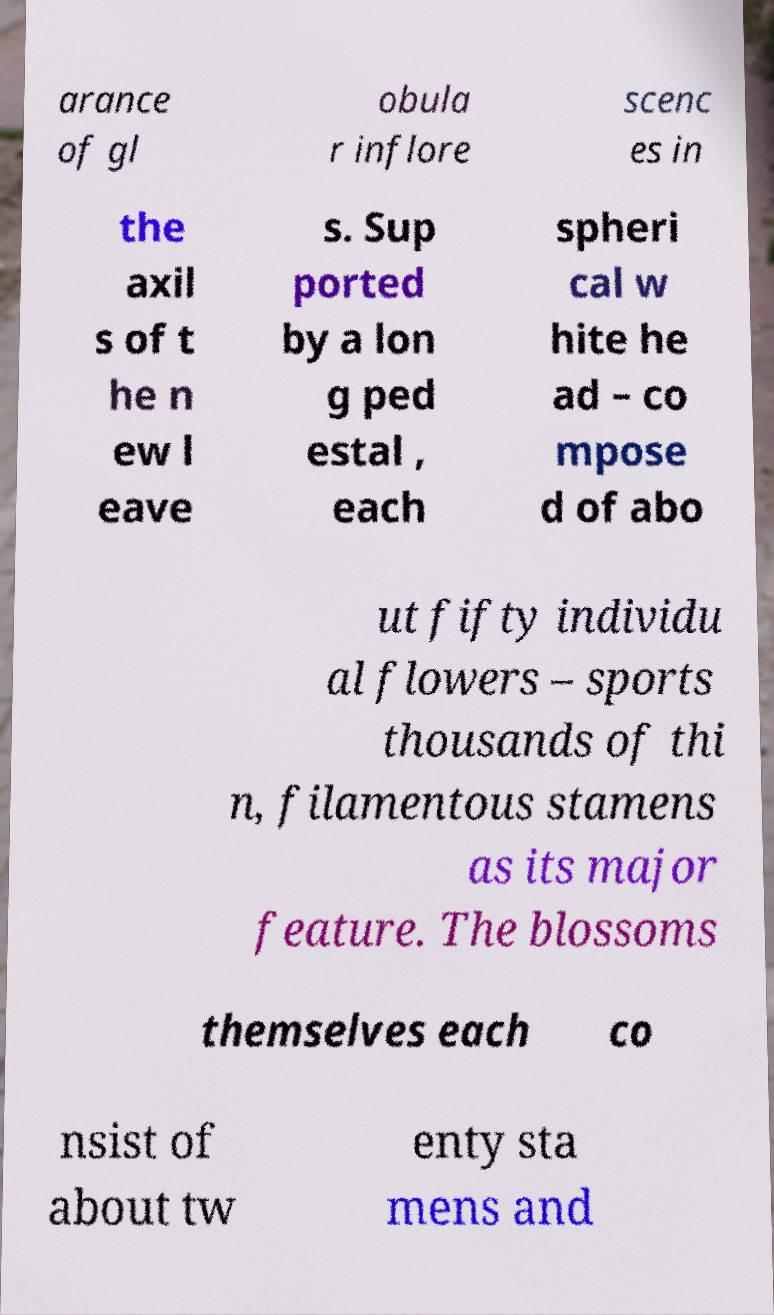What messages or text are displayed in this image? I need them in a readable, typed format. arance of gl obula r inflore scenc es in the axil s of t he n ew l eave s. Sup ported by a lon g ped estal , each spheri cal w hite he ad – co mpose d of abo ut fifty individu al flowers – sports thousands of thi n, filamentous stamens as its major feature. The blossoms themselves each co nsist of about tw enty sta mens and 